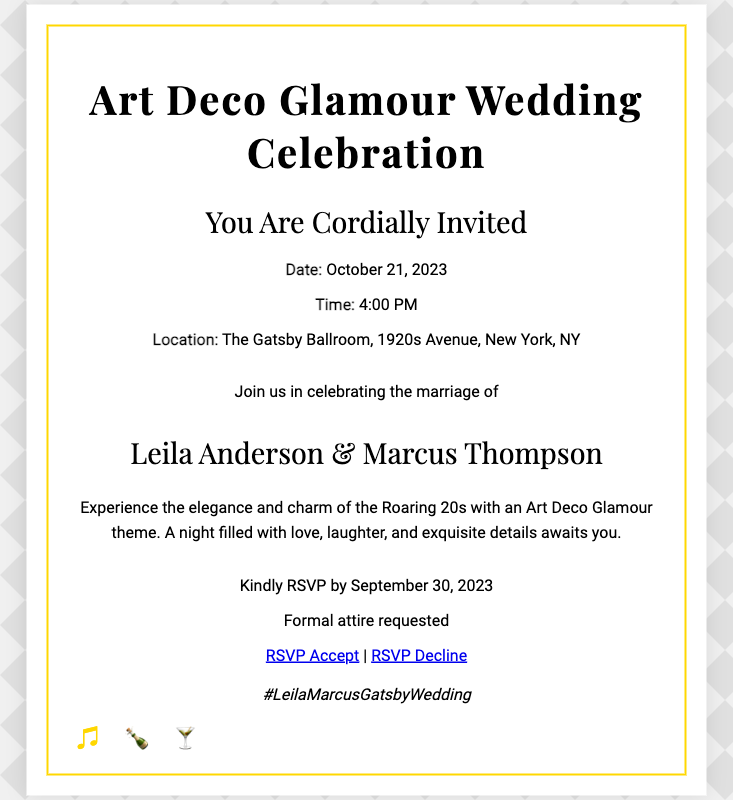What is the date of the wedding? The date of the wedding is specified in the details section of the invitation.
Answer: October 21, 2023 What time does the wedding start? The starting time of the wedding is mentioned along with the date and location.
Answer: 4:00 PM Where is the wedding taking place? The location of the wedding is listed under the details section.
Answer: The Gatsby Ballroom, 1920s Avenue, New York, NY Who are the couple getting married? The names of the couple are highlighted in the message section of the invitation.
Answer: Leila Anderson & Marcus Thompson What theme is the wedding based on? The theme of the wedding is stated prominently in the invitation title.
Answer: Art Deco Glamour When is the RSVP deadline? The RSVP deadline is indicated specifically in the rsvp section of the invitation.
Answer: September 30, 2023 What attire is requested for the wedding? The type of attire requested is mentioned in the rsvp section.
Answer: Formal attire What is the hashtag associated with the wedding? The wedding hashtag is found in the social section of the invitation.
Answer: #LeilaMarcusGatsbyWedding How many icons are displayed in the invitation? The number of icons shown at the bottom of the invitation indicates the total count.
Answer: 3 